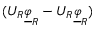<formula> <loc_0><loc_0><loc_500><loc_500>( U _ { R } \underline { \varphi } _ { R } - U _ { R } \underline { \varphi } _ { R } )</formula> 